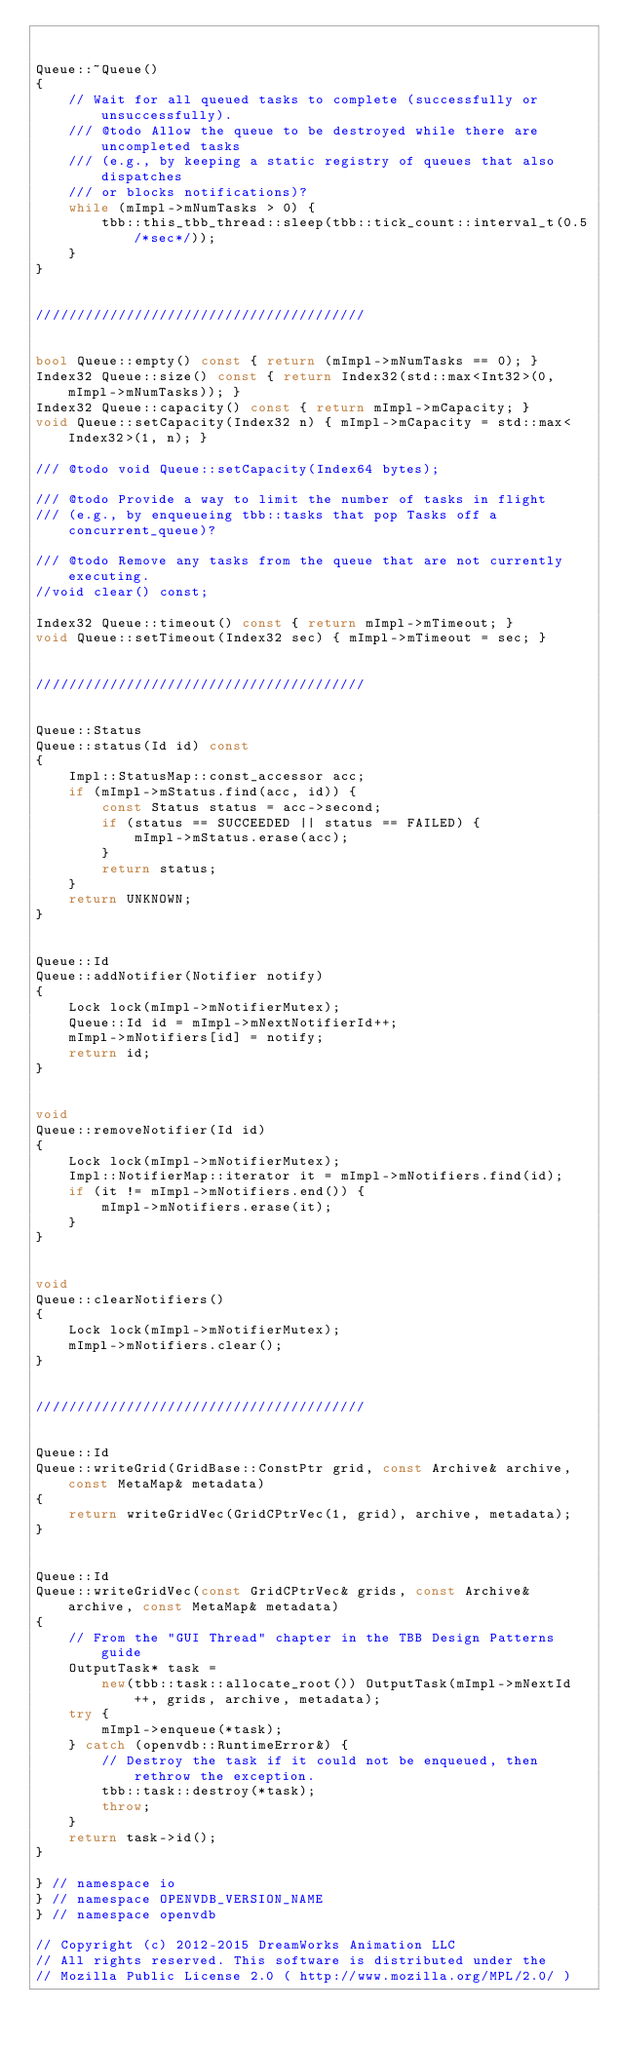<code> <loc_0><loc_0><loc_500><loc_500><_C++_>

Queue::~Queue()
{
    // Wait for all queued tasks to complete (successfully or unsuccessfully).
    /// @todo Allow the queue to be destroyed while there are uncompleted tasks
    /// (e.g., by keeping a static registry of queues that also dispatches
    /// or blocks notifications)?
    while (mImpl->mNumTasks > 0) {
        tbb::this_tbb_thread::sleep(tbb::tick_count::interval_t(0.5/*sec*/));
    }
}


////////////////////////////////////////


bool Queue::empty() const { return (mImpl->mNumTasks == 0); }
Index32 Queue::size() const { return Index32(std::max<Int32>(0, mImpl->mNumTasks)); }
Index32 Queue::capacity() const { return mImpl->mCapacity; }
void Queue::setCapacity(Index32 n) { mImpl->mCapacity = std::max<Index32>(1, n); }

/// @todo void Queue::setCapacity(Index64 bytes);

/// @todo Provide a way to limit the number of tasks in flight
/// (e.g., by enqueueing tbb::tasks that pop Tasks off a concurrent_queue)?

/// @todo Remove any tasks from the queue that are not currently executing.
//void clear() const;

Index32 Queue::timeout() const { return mImpl->mTimeout; }
void Queue::setTimeout(Index32 sec) { mImpl->mTimeout = sec; }


////////////////////////////////////////


Queue::Status
Queue::status(Id id) const
{
    Impl::StatusMap::const_accessor acc;
    if (mImpl->mStatus.find(acc, id)) {
        const Status status = acc->second;
        if (status == SUCCEEDED || status == FAILED) {
            mImpl->mStatus.erase(acc);
        }
        return status;
    }
    return UNKNOWN;
}


Queue::Id
Queue::addNotifier(Notifier notify)
{
    Lock lock(mImpl->mNotifierMutex);
    Queue::Id id = mImpl->mNextNotifierId++;
    mImpl->mNotifiers[id] = notify;
    return id;
}


void
Queue::removeNotifier(Id id)
{
    Lock lock(mImpl->mNotifierMutex);
    Impl::NotifierMap::iterator it = mImpl->mNotifiers.find(id);
    if (it != mImpl->mNotifiers.end()) {
        mImpl->mNotifiers.erase(it);
    }
}


void
Queue::clearNotifiers()
{
    Lock lock(mImpl->mNotifierMutex);
    mImpl->mNotifiers.clear();
}


////////////////////////////////////////


Queue::Id
Queue::writeGrid(GridBase::ConstPtr grid, const Archive& archive, const MetaMap& metadata)
{
    return writeGridVec(GridCPtrVec(1, grid), archive, metadata);
}


Queue::Id
Queue::writeGridVec(const GridCPtrVec& grids, const Archive& archive, const MetaMap& metadata)
{
    // From the "GUI Thread" chapter in the TBB Design Patterns guide
    OutputTask* task =
        new(tbb::task::allocate_root()) OutputTask(mImpl->mNextId++, grids, archive, metadata);
    try {
        mImpl->enqueue(*task);
    } catch (openvdb::RuntimeError&) {
        // Destroy the task if it could not be enqueued, then rethrow the exception.
        tbb::task::destroy(*task);
        throw;
    }
    return task->id();
}

} // namespace io
} // namespace OPENVDB_VERSION_NAME
} // namespace openvdb

// Copyright (c) 2012-2015 DreamWorks Animation LLC
// All rights reserved. This software is distributed under the
// Mozilla Public License 2.0 ( http://www.mozilla.org/MPL/2.0/ )
</code> 